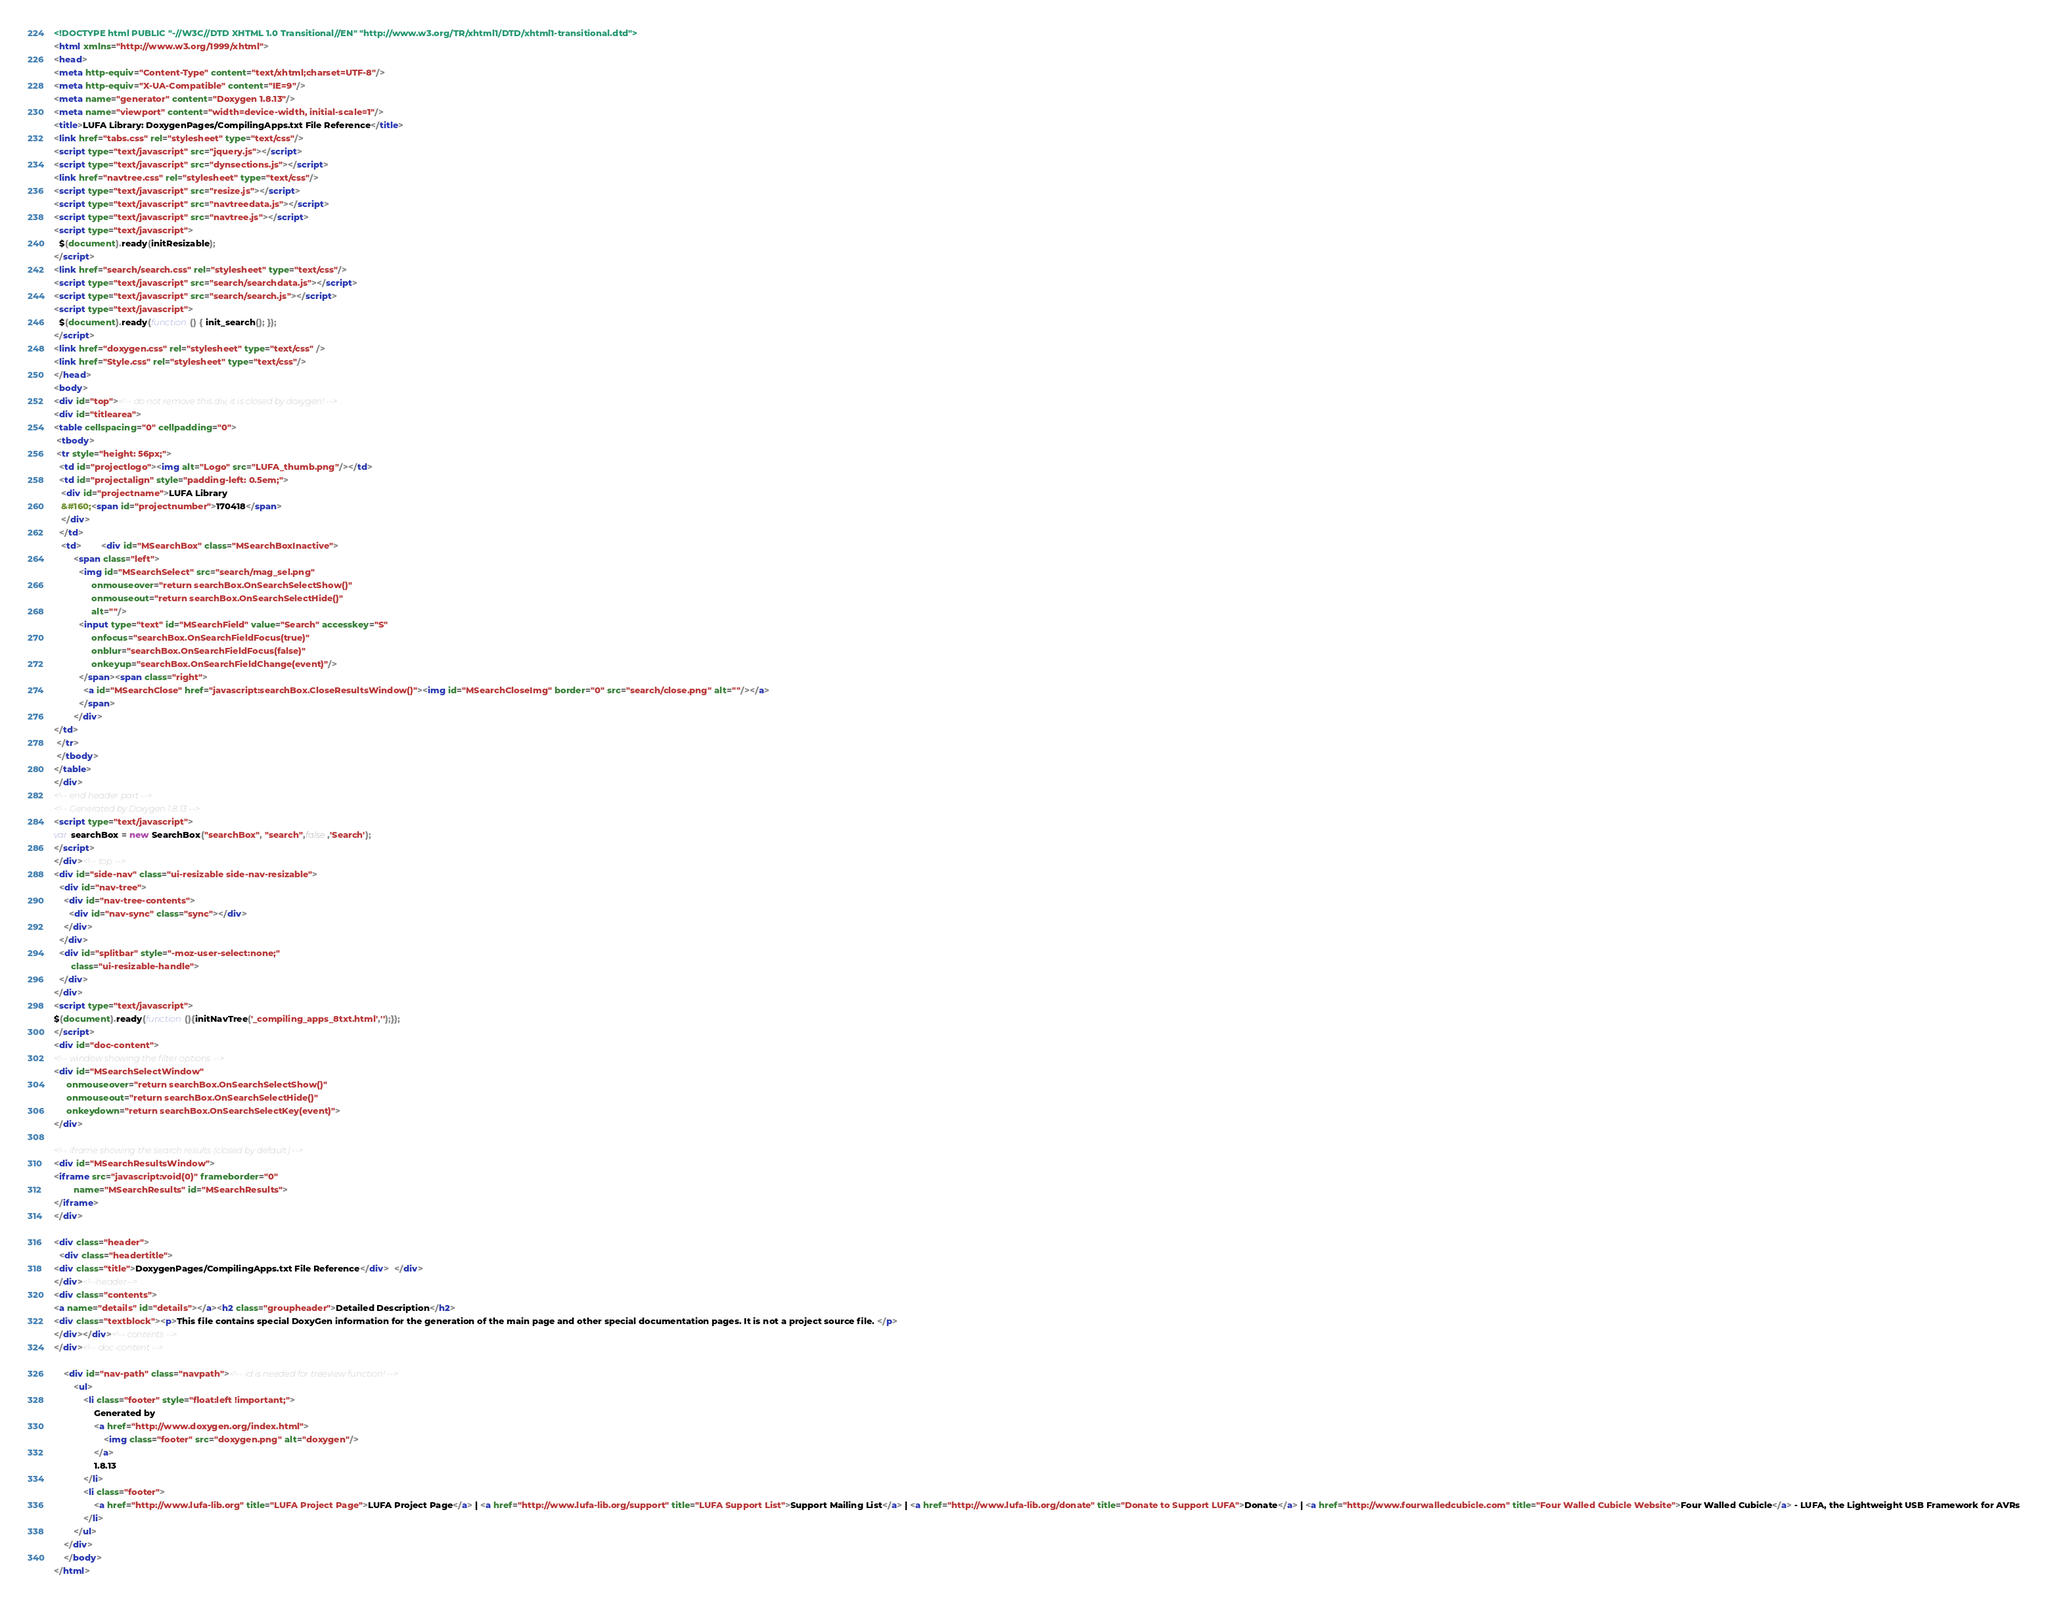<code> <loc_0><loc_0><loc_500><loc_500><_HTML_><!DOCTYPE html PUBLIC "-//W3C//DTD XHTML 1.0 Transitional//EN" "http://www.w3.org/TR/xhtml1/DTD/xhtml1-transitional.dtd">
<html xmlns="http://www.w3.org/1999/xhtml">
<head>
<meta http-equiv="Content-Type" content="text/xhtml;charset=UTF-8"/>
<meta http-equiv="X-UA-Compatible" content="IE=9"/>
<meta name="generator" content="Doxygen 1.8.13"/>
<meta name="viewport" content="width=device-width, initial-scale=1"/>
<title>LUFA Library: DoxygenPages/CompilingApps.txt File Reference</title>
<link href="tabs.css" rel="stylesheet" type="text/css"/>
<script type="text/javascript" src="jquery.js"></script>
<script type="text/javascript" src="dynsections.js"></script>
<link href="navtree.css" rel="stylesheet" type="text/css"/>
<script type="text/javascript" src="resize.js"></script>
<script type="text/javascript" src="navtreedata.js"></script>
<script type="text/javascript" src="navtree.js"></script>
<script type="text/javascript">
  $(document).ready(initResizable);
</script>
<link href="search/search.css" rel="stylesheet" type="text/css"/>
<script type="text/javascript" src="search/searchdata.js"></script>
<script type="text/javascript" src="search/search.js"></script>
<script type="text/javascript">
  $(document).ready(function() { init_search(); });
</script>
<link href="doxygen.css" rel="stylesheet" type="text/css" />
<link href="Style.css" rel="stylesheet" type="text/css"/>
</head>
<body>
<div id="top"><!-- do not remove this div, it is closed by doxygen! -->
<div id="titlearea">
<table cellspacing="0" cellpadding="0">
 <tbody>
 <tr style="height: 56px;">
  <td id="projectlogo"><img alt="Logo" src="LUFA_thumb.png"/></td>
  <td id="projectalign" style="padding-left: 0.5em;">
   <div id="projectname">LUFA Library
   &#160;<span id="projectnumber">170418</span>
   </div>
  </td>
   <td>        <div id="MSearchBox" class="MSearchBoxInactive">
        <span class="left">
          <img id="MSearchSelect" src="search/mag_sel.png"
               onmouseover="return searchBox.OnSearchSelectShow()"
               onmouseout="return searchBox.OnSearchSelectHide()"
               alt=""/>
          <input type="text" id="MSearchField" value="Search" accesskey="S"
               onfocus="searchBox.OnSearchFieldFocus(true)" 
               onblur="searchBox.OnSearchFieldFocus(false)" 
               onkeyup="searchBox.OnSearchFieldChange(event)"/>
          </span><span class="right">
            <a id="MSearchClose" href="javascript:searchBox.CloseResultsWindow()"><img id="MSearchCloseImg" border="0" src="search/close.png" alt=""/></a>
          </span>
        </div>
</td>
 </tr>
 </tbody>
</table>
</div>
<!-- end header part -->
<!-- Generated by Doxygen 1.8.13 -->
<script type="text/javascript">
var searchBox = new SearchBox("searchBox", "search",false,'Search');
</script>
</div><!-- top -->
<div id="side-nav" class="ui-resizable side-nav-resizable">
  <div id="nav-tree">
    <div id="nav-tree-contents">
      <div id="nav-sync" class="sync"></div>
    </div>
  </div>
  <div id="splitbar" style="-moz-user-select:none;" 
       class="ui-resizable-handle">
  </div>
</div>
<script type="text/javascript">
$(document).ready(function(){initNavTree('_compiling_apps_8txt.html','');});
</script>
<div id="doc-content">
<!-- window showing the filter options -->
<div id="MSearchSelectWindow"
     onmouseover="return searchBox.OnSearchSelectShow()"
     onmouseout="return searchBox.OnSearchSelectHide()"
     onkeydown="return searchBox.OnSearchSelectKey(event)">
</div>

<!-- iframe showing the search results (closed by default) -->
<div id="MSearchResultsWindow">
<iframe src="javascript:void(0)" frameborder="0" 
        name="MSearchResults" id="MSearchResults">
</iframe>
</div>

<div class="header">
  <div class="headertitle">
<div class="title">DoxygenPages/CompilingApps.txt File Reference</div>  </div>
</div><!--header-->
<div class="contents">
<a name="details" id="details"></a><h2 class="groupheader">Detailed Description</h2>
<div class="textblock"><p>This file contains special DoxyGen information for the generation of the main page and other special documentation pages. It is not a project source file. </p>
</div></div><!-- contents -->
</div><!-- doc-content -->

	<div id="nav-path" class="navpath"><!-- id is needed for treeview function! -->
		<ul>
			<li class="footer" style="float:left !important;">
				Generated by
				<a href="http://www.doxygen.org/index.html">
					<img class="footer" src="doxygen.png" alt="doxygen"/>
				</a>
				1.8.13
			</li>
			<li class="footer">
				<a href="http://www.lufa-lib.org" title="LUFA Project Page">LUFA Project Page</a> | <a href="http://www.lufa-lib.org/support" title="LUFA Support List">Support Mailing List</a> | <a href="http://www.lufa-lib.org/donate" title="Donate to Support LUFA">Donate</a> | <a href="http://www.fourwalledcubicle.com" title="Four Walled Cubicle Website">Four Walled Cubicle</a> - LUFA, the Lightweight USB Framework for AVRs
			</li>
		</ul>
	</div>
	</body>
</html></code> 